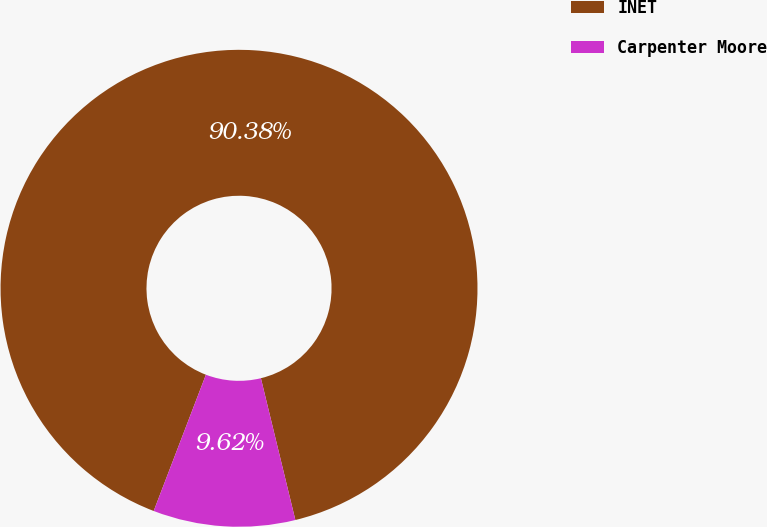<chart> <loc_0><loc_0><loc_500><loc_500><pie_chart><fcel>INET<fcel>Carpenter Moore<nl><fcel>90.38%<fcel>9.62%<nl></chart> 